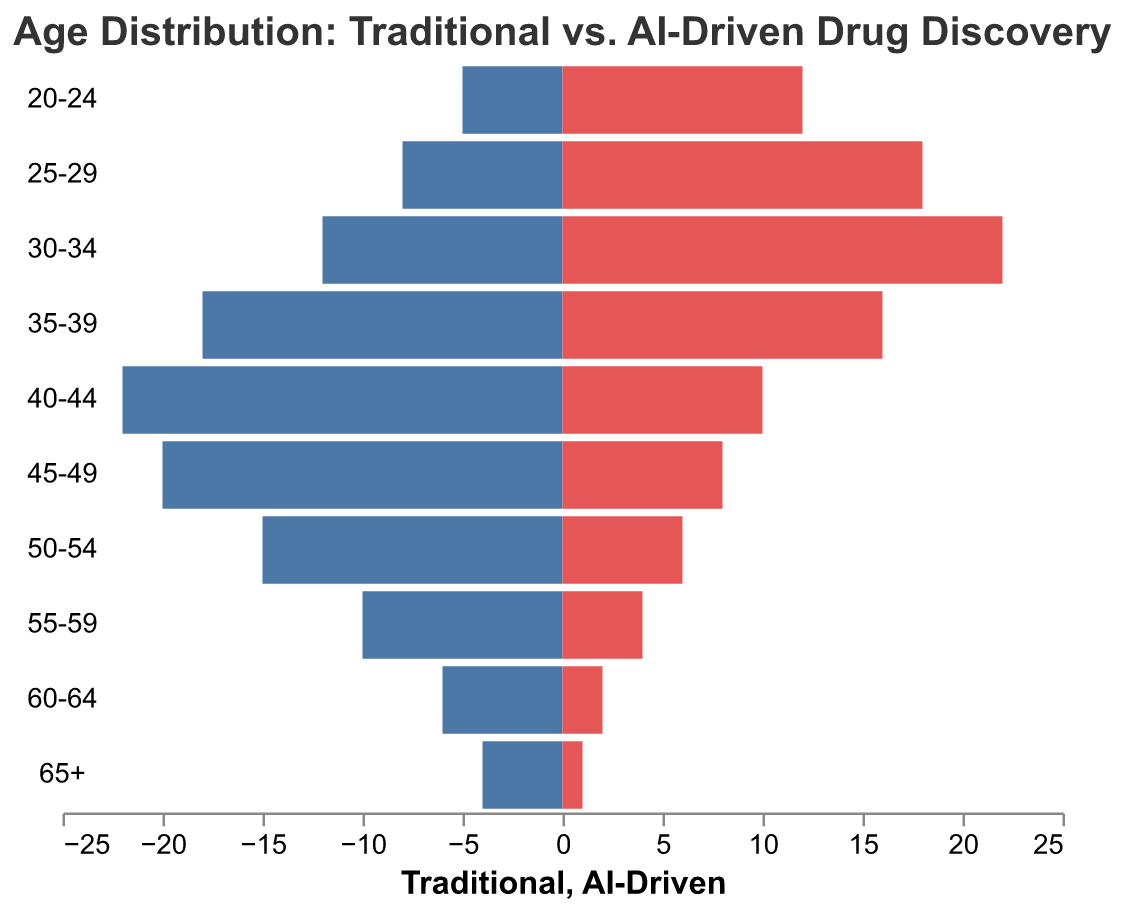How many age groups are represented in each department? The population pyramid shows age groups on the y-axis. Count each age group from "20-24" to "65+."
Answer: 10 Which department has more scientists in the 30-34 age group? Compare the values for the 30-34 age group in both Traditional (12) and AI-Driven (22).
Answer: AI-Driven What age group has the highest number of scientists in the Traditional department? Look for the highest bar for Traditional, which corresponds to the 40-44 age group with 22 scientists.
Answer: 40-44 What is the difference in the number of scientists between the Traditional and AI-Driven departments for the 50-54 age group? Subtract the number of AI-Driven scientists (6) from the Traditional ones (15) in the 50-54 age group.
Answer: 9 Which age group has more scientists in the AI-Driven department compared to the Traditional department? Compare the bars for each age group and identify where the AI-Driven bar is longer. This happens in the 20-24, 25-29, and 30-34 age groups.
Answer: 20-24, 25-29, 30-34 What is the cumulative number of scientists in the AI-Driven department for the age groups 40-44 and above? Sum the AI-Driven counts for 40-44 (10), 45-49 (8), 50-54 (6), 55-59 (4), 60-64 (2), and 65+ (1). The total is 10 + 8 + 6 + 4 + 2 + 1 = 31.
Answer: 31 In which age group is the difference between Traditional and AI-Driven the smallest? Calculate the absolute differences for each age group and find the smallest: 20-24 (7), 25-29 (10), 30-34 (10), 35-39 (2), 40-44 (12), 45-49 (12), 50-54 (9), 55-59 (6), 60-64 (4), 65+ (3). The smallest difference is 2 in the 35-39 age group.
Answer: 35-39 Are there any age groups where the number of scientists is equal in both departments? Compare both values in each age group. There are no age groups where values are equal.
Answer: No What percentage of the Traditional department's scientists are in the 35-39 age group? Divide the number of Traditional scientists in the 35-39 age group (18) by the total number in the Traditional department (5+8+12+18+22+20+15+10+6+4 = 120). Then multiply by 100%. (18/120) * 100% = 15%.
Answer: 15% What trend is observed in the Traditional department’s age distribution compared to the AI-Driven department? The Traditional department has more older scientists, shown by the higher counts in older age groups, while the AI-Driven department has more younger scientists, indicated by higher counts in the younger age groups.
Answer: Traditional: more older, AI-Driven: more younger 